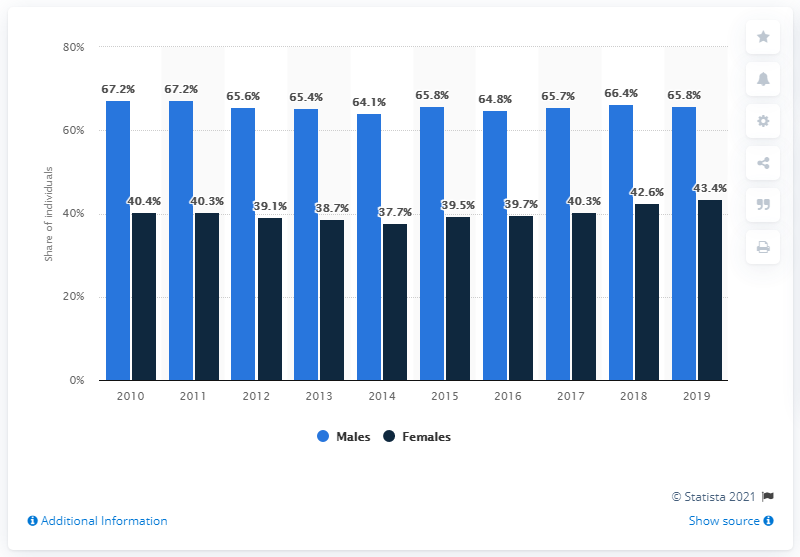Highlight a few significant elements in this photo. In 2019, the percentage of males who consumed wine in Italy was 65.8%. 